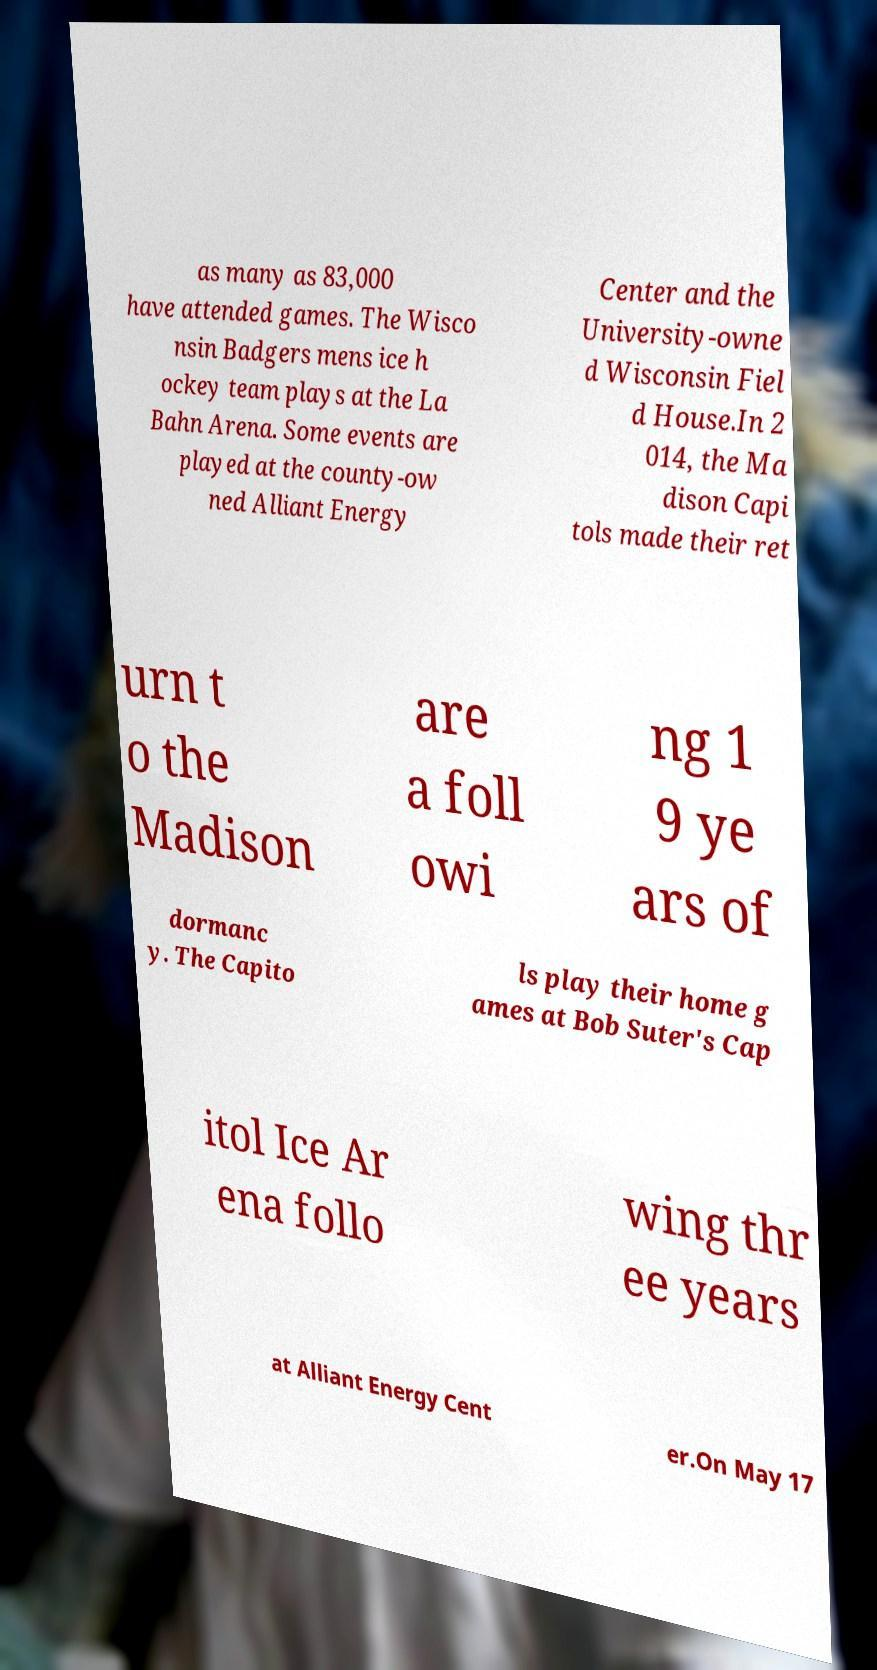There's text embedded in this image that I need extracted. Can you transcribe it verbatim? as many as 83,000 have attended games. The Wisco nsin Badgers mens ice h ockey team plays at the La Bahn Arena. Some events are played at the county-ow ned Alliant Energy Center and the University-owne d Wisconsin Fiel d House.In 2 014, the Ma dison Capi tols made their ret urn t o the Madison are a foll owi ng 1 9 ye ars of dormanc y. The Capito ls play their home g ames at Bob Suter's Cap itol Ice Ar ena follo wing thr ee years at Alliant Energy Cent er.On May 17 